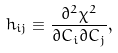Convert formula to latex. <formula><loc_0><loc_0><loc_500><loc_500>h _ { i j } \equiv \frac { \partial ^ { 2 } \chi ^ { 2 } } { \partial C _ { i } \partial C _ { j } } ,</formula> 